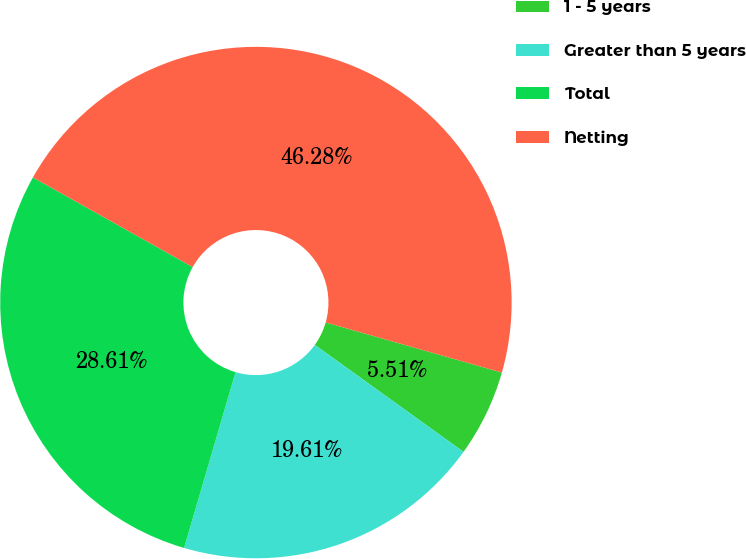<chart> <loc_0><loc_0><loc_500><loc_500><pie_chart><fcel>1 - 5 years<fcel>Greater than 5 years<fcel>Total<fcel>Netting<nl><fcel>5.51%<fcel>19.61%<fcel>28.61%<fcel>46.28%<nl></chart> 